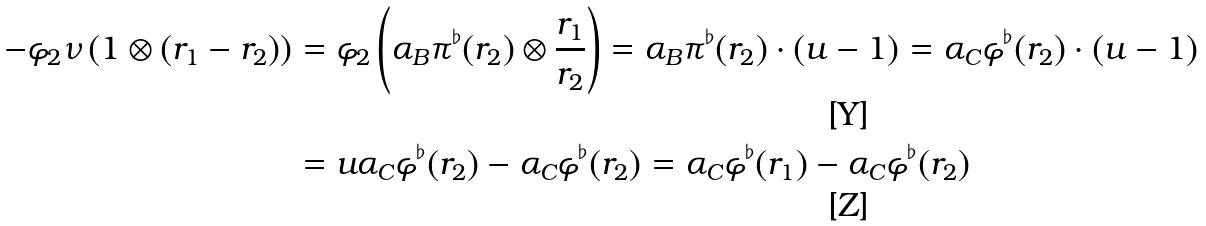<formula> <loc_0><loc_0><loc_500><loc_500>- \varphi _ { 2 } \nu \left ( 1 \otimes ( r _ { 1 } - r _ { 2 } ) \right ) & = \varphi _ { 2 } \left ( \alpha _ { B } \pi ^ { \flat } ( r _ { 2 } ) \otimes \frac { r _ { 1 } } { r _ { 2 } } \right ) = \alpha _ { B } \pi ^ { \flat } ( r _ { 2 } ) \cdot ( u - 1 ) = \alpha _ { C } \varphi ^ { \flat } ( r _ { 2 } ) \cdot ( u - 1 ) \\ & = u \alpha _ { C } \varphi ^ { \flat } ( r _ { 2 } ) - \alpha _ { C } \varphi ^ { \flat } ( r _ { 2 } ) = \alpha _ { C } \varphi ^ { \flat } ( r _ { 1 } ) - \alpha _ { C } \varphi ^ { \flat } ( r _ { 2 } )</formula> 